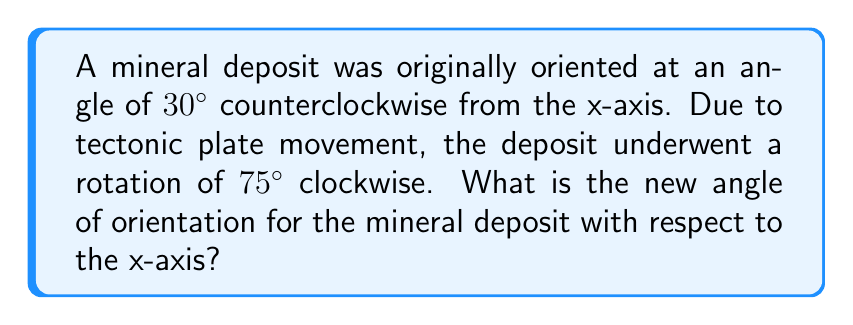Solve this math problem. To solve this problem, we need to consider the following steps:

1) First, let's establish our coordinate system:
   - Positive angles are measured counterclockwise from the x-axis
   - Negative angles are measured clockwise from the x-axis

2) The original orientation of the mineral deposit:
   $\theta_1 = 30^\circ$ (counterclockwise from x-axis)

3) The rotation due to tectonic plate movement:
   $\theta_2 = -75^\circ$ (clockwise, so it's negative)

4) To find the new orientation, we add these angles:
   $$\theta_{new} = \theta_1 + \theta_2 = 30^\circ + (-75^\circ) = -45^\circ$$

5) However, we typically express angles in the range $[0^\circ, 360^\circ)$ or $(-180^\circ, 180^\circ]$. In this case, $-45^\circ$ is already in the latter range, so no further adjustment is needed.

6) To interpret this result:
   - $-45^\circ$ means the mineral deposit is now oriented $45^\circ$ clockwise from the x-axis.
   - This is equivalent to $315^\circ$ counterclockwise from the x-axis.

[asy]
import geometry;

size(200);
draw((-2,0)--(2,0),arrow=Arrow(TeXHead));
draw((0,-2)--(0,2),arrow=Arrow(TeXHead));

draw((0,0)--(1.414,-1.414),blue,arrow=Arrow(TeXHead));
label("New orientation", (0.9,-0.9), SE, blue);

draw(arc((0,0), 0.5, 0, -45), red, arrow=Arrow(TeXHead));
label("$-45^\circ$", (0.4,-0.2), NE, red);
[/asy]
Answer: The new angle of orientation for the mineral deposit is $-45^\circ$ or $315^\circ$ with respect to the x-axis. 